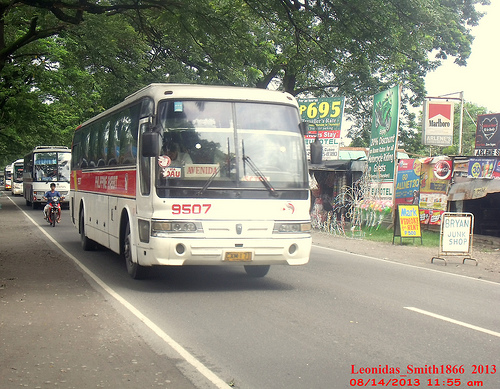Please provide the bounding box coordinate of the region this sentence describes: reflections in a windshield. The bounding box coordinate for reflections in a windshield is [0.07, 0.41, 0.14, 0.47]. 